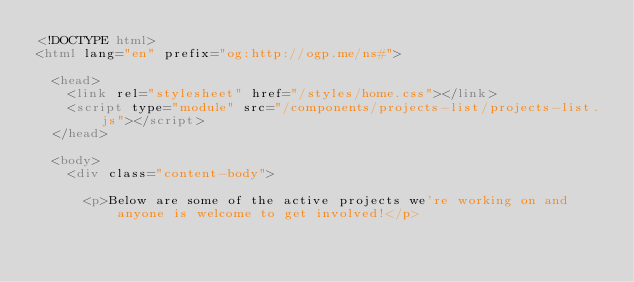Convert code to text. <code><loc_0><loc_0><loc_500><loc_500><_HTML_><!DOCTYPE html>
<html lang="en" prefix="og:http://ogp.me/ns#">
  
  <head>
    <link rel="stylesheet" href="/styles/home.css"></link>
    <script type="module" src="/components/projects-list/projects-list.js"></script>
  </head>

  <body>
    <div class="content-body">
      
      <p>Below are some of the active projects we're working on and anyone is welcome to get involved!</p>
</code> 